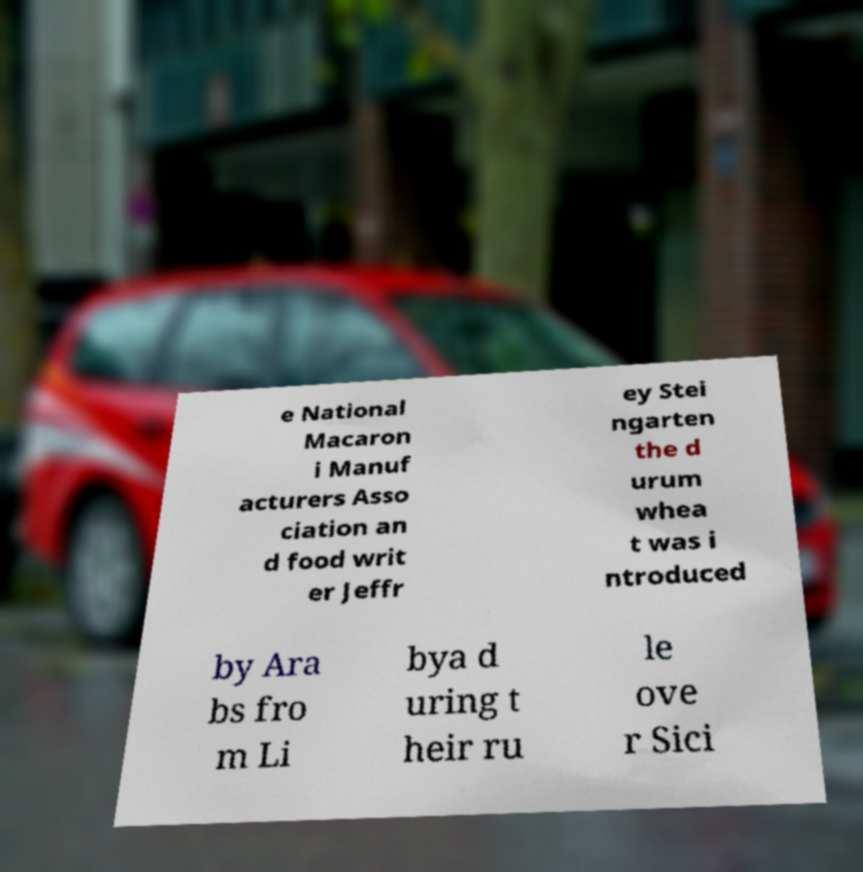Please read and relay the text visible in this image. What does it say? e National Macaron i Manuf acturers Asso ciation an d food writ er Jeffr ey Stei ngarten the d urum whea t was i ntroduced by Ara bs fro m Li bya d uring t heir ru le ove r Sici 